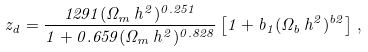<formula> <loc_0><loc_0><loc_500><loc_500>z _ { d } = \frac { 1 2 9 1 ( \Omega _ { m } \, h ^ { 2 } ) ^ { 0 . 2 5 1 } } { 1 + 0 . 6 5 9 ( \Omega _ { m } \, h ^ { 2 } ) ^ { 0 . 8 2 8 } } \left [ 1 + b _ { 1 } ( \Omega _ { b } \, h ^ { 2 } ) ^ { b 2 } \right ] \, ,</formula> 